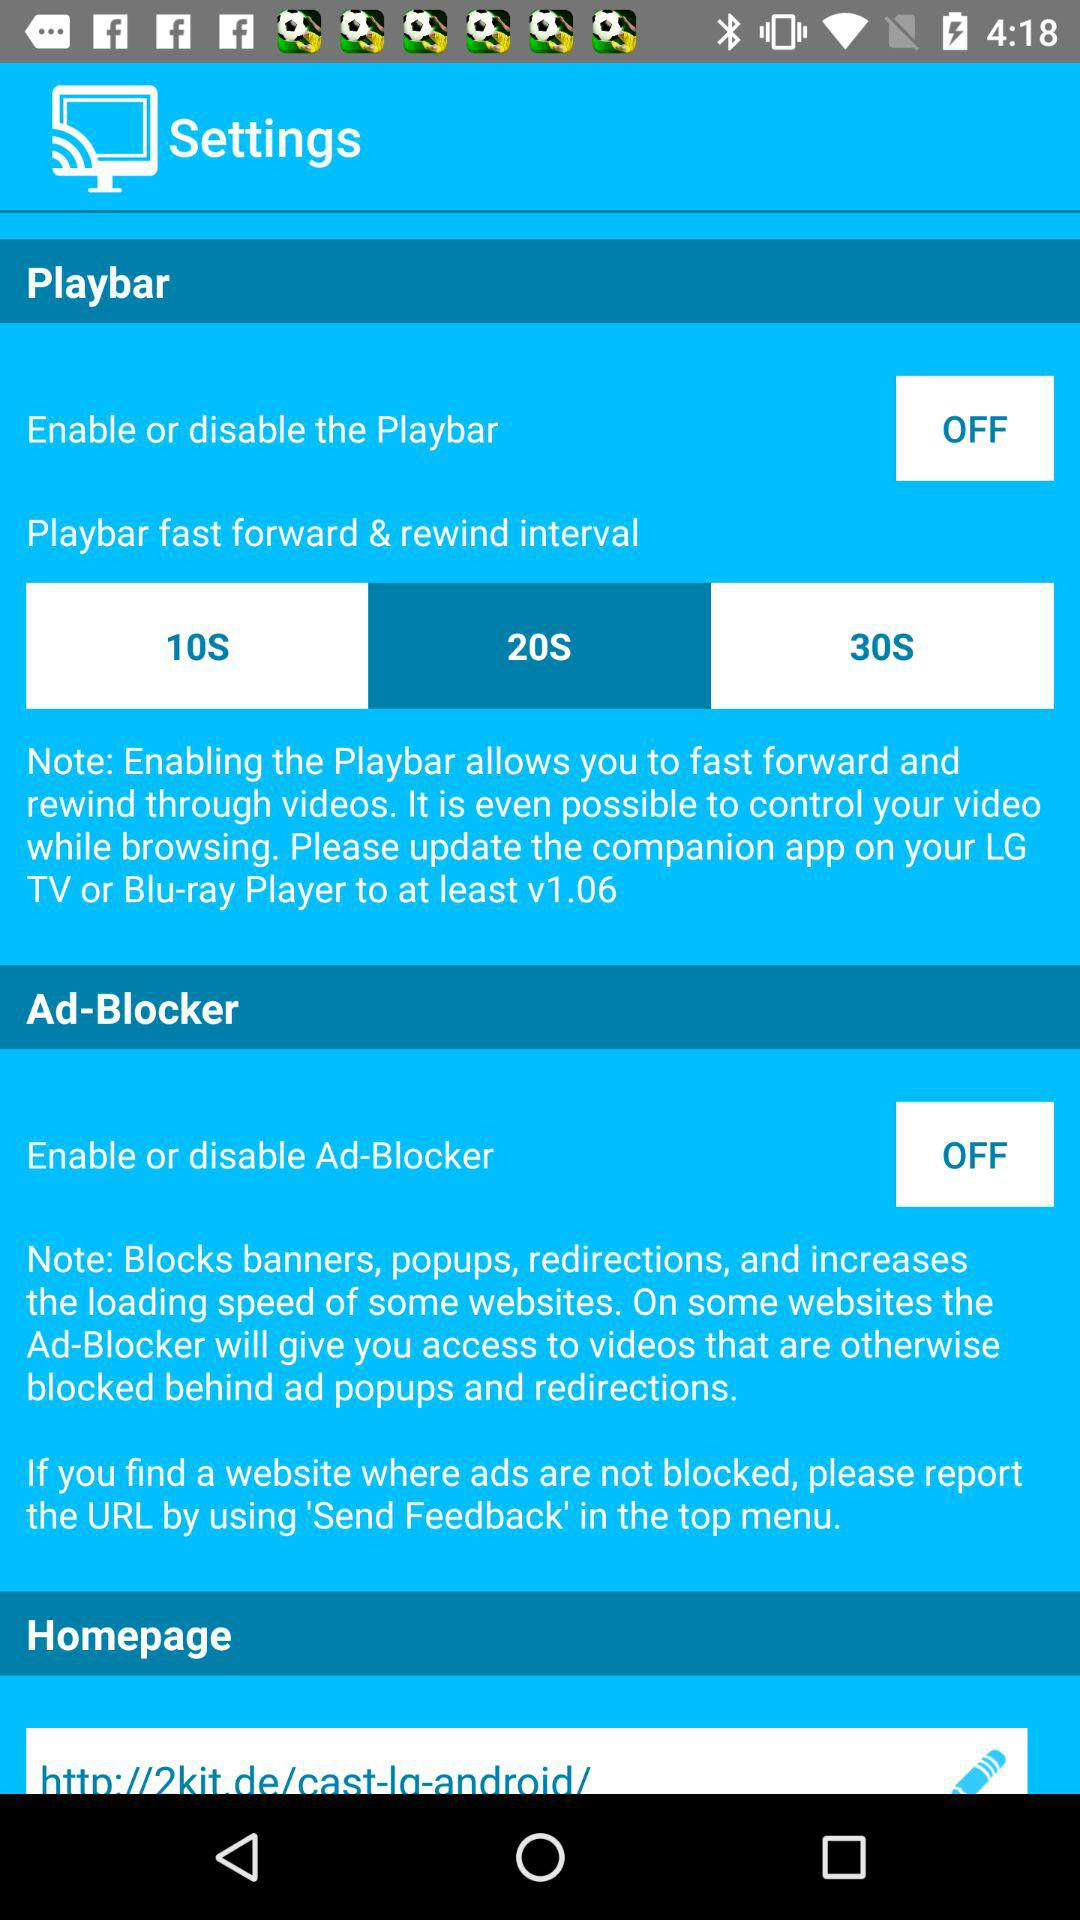Which option is selected in the "Playbar fast forward & rewind interval"? The selected option is 20S. 